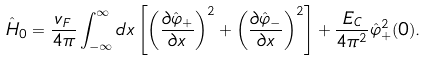<formula> <loc_0><loc_0><loc_500><loc_500>\hat { H } _ { 0 } = \frac { v _ { F } } { 4 \pi } \int _ { - \infty } ^ { \infty } d x \left [ \left ( \frac { \partial \hat { \varphi } _ { + } } { \partial x } \right ) ^ { 2 } + \left ( \frac { \partial \hat { \varphi } _ { - } } { \partial x } \right ) ^ { 2 } \right ] + \frac { E _ { C } } { 4 \pi ^ { 2 } } \hat { \varphi } _ { + } ^ { 2 } ( 0 ) .</formula> 